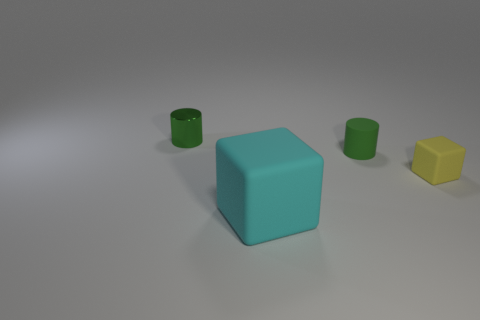Does the tiny metallic thing have the same shape as the yellow thing?
Your answer should be very brief. No. What material is the green object that is on the left side of the cylinder that is in front of the cylinder to the left of the large cyan rubber object?
Offer a very short reply. Metal. What material is the thing that is to the right of the tiny cylinder that is in front of the tiny green shiny cylinder made of?
Your response must be concise. Rubber. Are there fewer small yellow rubber blocks left of the tiny yellow rubber object than green cylinders?
Keep it short and to the point. Yes. There is a tiny green thing left of the big cyan thing; what is its shape?
Your answer should be compact. Cylinder. Does the green matte object have the same size as the green cylinder that is left of the cyan block?
Your answer should be compact. Yes. Are there any large brown things made of the same material as the tiny yellow thing?
Provide a short and direct response. No. How many spheres are green rubber things or large rubber objects?
Provide a succinct answer. 0. Are there any small green metallic cylinders to the right of the tiny rubber block that is right of the tiny green matte thing?
Offer a terse response. No. Is the number of small gray rubber blocks less than the number of large rubber blocks?
Your answer should be very brief. Yes. 